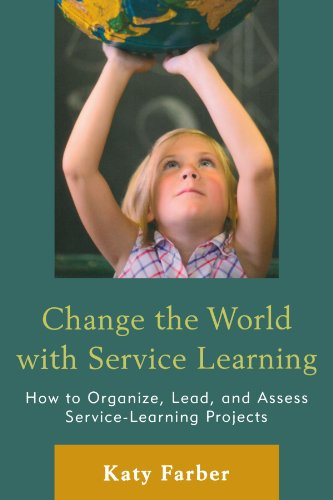Is this a financial book? No, this book is not focused on finance. It is an educational resource that guides readers on how to engage students in service learning projects which benefit communities and teach civic responsibility. 